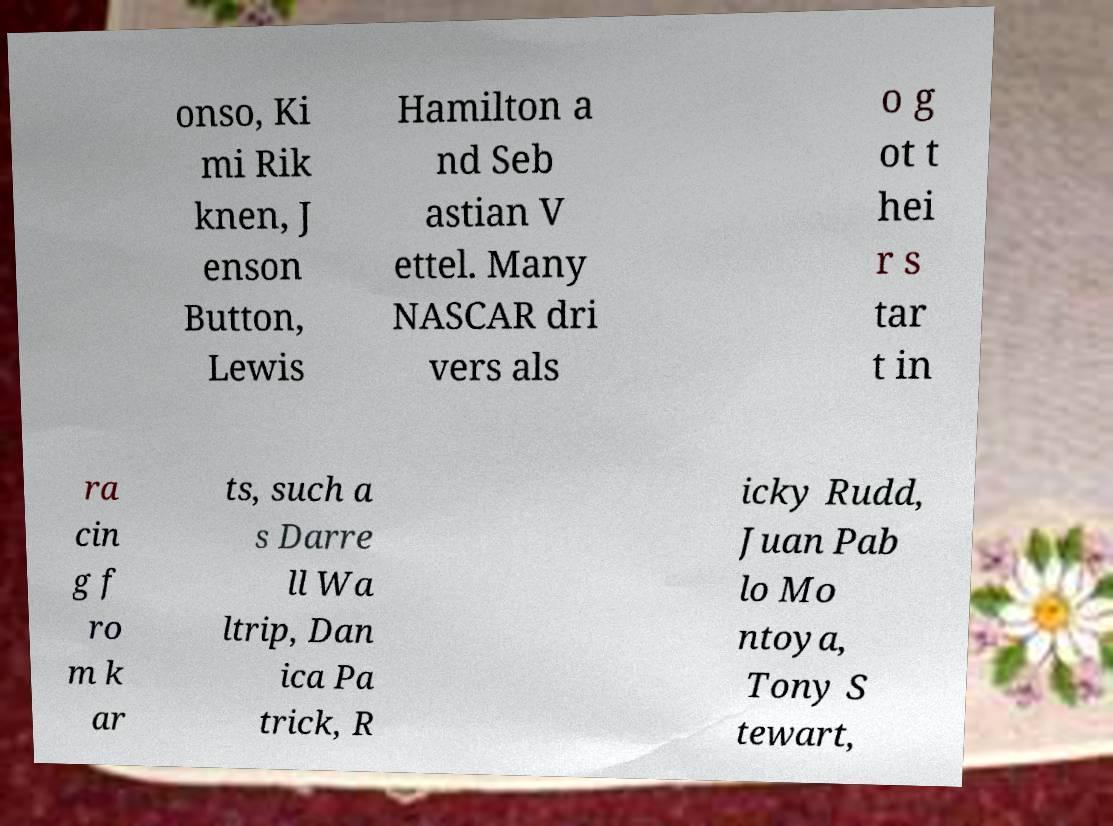Please identify and transcribe the text found in this image. onso, Ki mi Rik knen, J enson Button, Lewis Hamilton a nd Seb astian V ettel. Many NASCAR dri vers als o g ot t hei r s tar t in ra cin g f ro m k ar ts, such a s Darre ll Wa ltrip, Dan ica Pa trick, R icky Rudd, Juan Pab lo Mo ntoya, Tony S tewart, 